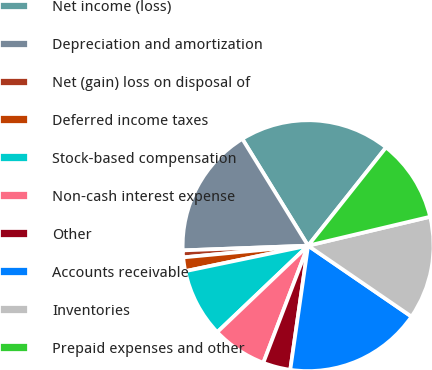Convert chart to OTSL. <chart><loc_0><loc_0><loc_500><loc_500><pie_chart><fcel>Net income (loss)<fcel>Depreciation and amortization<fcel>Net (gain) loss on disposal of<fcel>Deferred income taxes<fcel>Stock-based compensation<fcel>Non-cash interest expense<fcel>Other<fcel>Accounts receivable<fcel>Inventories<fcel>Prepaid expenses and other<nl><fcel>19.46%<fcel>16.81%<fcel>0.89%<fcel>1.77%<fcel>8.85%<fcel>7.08%<fcel>3.54%<fcel>17.7%<fcel>13.27%<fcel>10.62%<nl></chart> 